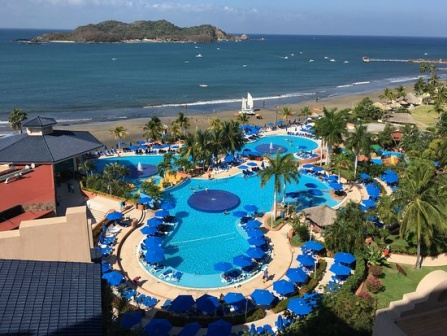Describe how the resort transitions from day to night and the types of activities it might offer during the evening. As the sun descends, casting a warm golden hue over the resort, the transition from day to evening brings a serene and magical transformation. The vibrant energy of daytime mellows into a more subdued, romantic, and enchanting atmosphere. Soft, ambient lighting begins to illuminate the walkways and pool area, casting gentle reflections on the water's surface. The resort’s buildings take on a cozy, intimate glow against the dusk sky.

The resort offers a range of enticing evening activities to delight its guests. Live music performances near the poolside or beach are common, providing a soothing backdrop as guests enjoy drinks from the bar. The pools, now beautifully lit with underwater lights, become a delightful location for an evening swim, offering a tranquil experience under the stars.

Al fresco dining options are plentiful, with restaurants setting up tables on terraces and along the beach, allowing guests to enjoy their meals accompanied by the sound of waves gently lapping against the shore. For those seeking entertainment, the resort might host themed nights, such as a beach bonfire evening with marshmallow roasting, storytelling, and acoustic guitar sessions.

For families, there could be organized movie nights either poolside or at an outdoor cinema setup, complete with popcorn and cozy seating. Kids’ clubs might offer night-time activities like stargazing with telescopes or night-time treasure hunts using lanterns to add a touch of adventure.

Couples might take the opportunity for a peaceful walk along the beach, hand in hand, savoring the moonlit scenery. The charming little shops around the resort stay open a bit longer, inviting guests to browse through local crafts and souvenirs, rounding out a perfect evening with a treasure to take home.

The resort’s nightly transition is a testament to its versatility, offering a perfect blend of relaxation and subtle excitement, ensuring every guest finds their ideal way to wind down from an exhilarating day. Imagine the experience of watching a rare celestial event, such as a lunar eclipse, while staying at this resort. Describe the scene and the resort’s possible plans to enhance this experience for guests. Witnessing a rare lunar eclipse at this resort would be an extraordinary experience, blending natural wonder with luxurious comfort. The resort would undoubtedly seize the opportunity to enhance this celestial event for its guests, creating an unforgettable evening.

In the early evening, as anticipation builds, the resort might organize a special outdoor event by the beach or the pool area. Lounge chairs and beach blankets would be arranged for optimal viewing positions, ensuring guests have a comfortable spot to gaze up at the night sky. The resort staff could provide telescopes for a more detailed view of the eclipse, along with informative guides to explain the science and significance behind the event.

To add to the ambiance, soft music would play in the background, carefully chosen to complement the awe-inspiring spectacle. The resort might also offer specialty cocktails and snacks inspired by the celestial theme, with names like 'Eclipse Elixir' and 'Moonlit Munchies' to add a fun and festive touch.

As the moon slowly begins to darken and turn a captivating red hue, guests would gather in hushed excitement. The resort could provide cozy blankets and pillows to ensure everyone is comfortable as the temperature cools down. For families with children, the staff might organize educational activities and storytelling sessions about myths and legends related to lunar eclipses, making the event as informative as it is mesmerizing.

The culmination of the event could involve a communal 'moonlight toast,' where guests of all ages raise their glasses in celebration of the extraordinary celestial display. The atmosphere would be one of shared wonder and unity, as people from all corners of the world come together to witness this magical moment in an idyllic setting.

Post-eclipse, the resort might offer themed keepsakes like postcards or photos capturing the moment, allowing guests to take a piece of this once-in-a-lifetime experience home with them. The night's event would undoubtedly leave a lasting impression, reinforcing the unique and memorable nature of their stay at the resort. 